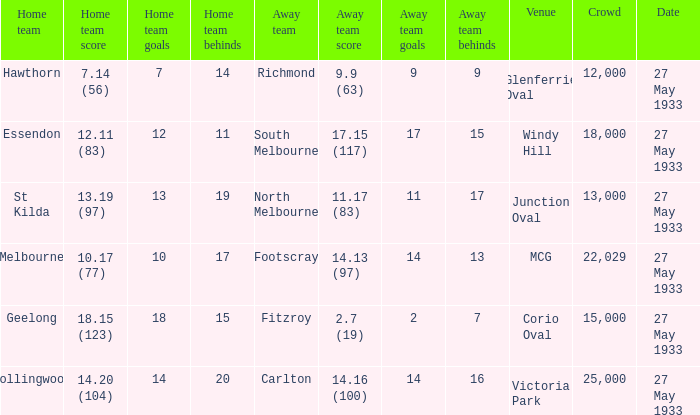In the match where the home team scored 14.20 (104), how many attendees were in the crowd? 25000.0. 